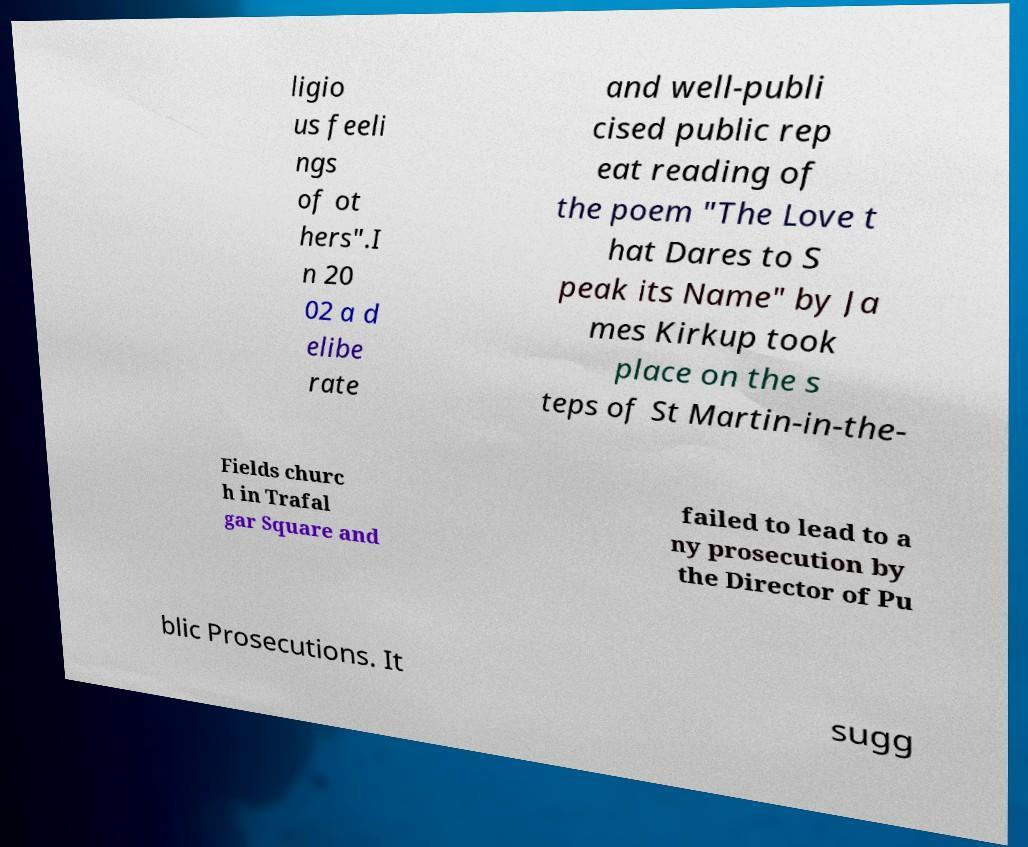I need the written content from this picture converted into text. Can you do that? ligio us feeli ngs of ot hers".I n 20 02 a d elibe rate and well-publi cised public rep eat reading of the poem "The Love t hat Dares to S peak its Name" by Ja mes Kirkup took place on the s teps of St Martin-in-the- Fields churc h in Trafal gar Square and failed to lead to a ny prosecution by the Director of Pu blic Prosecutions. It sugg 